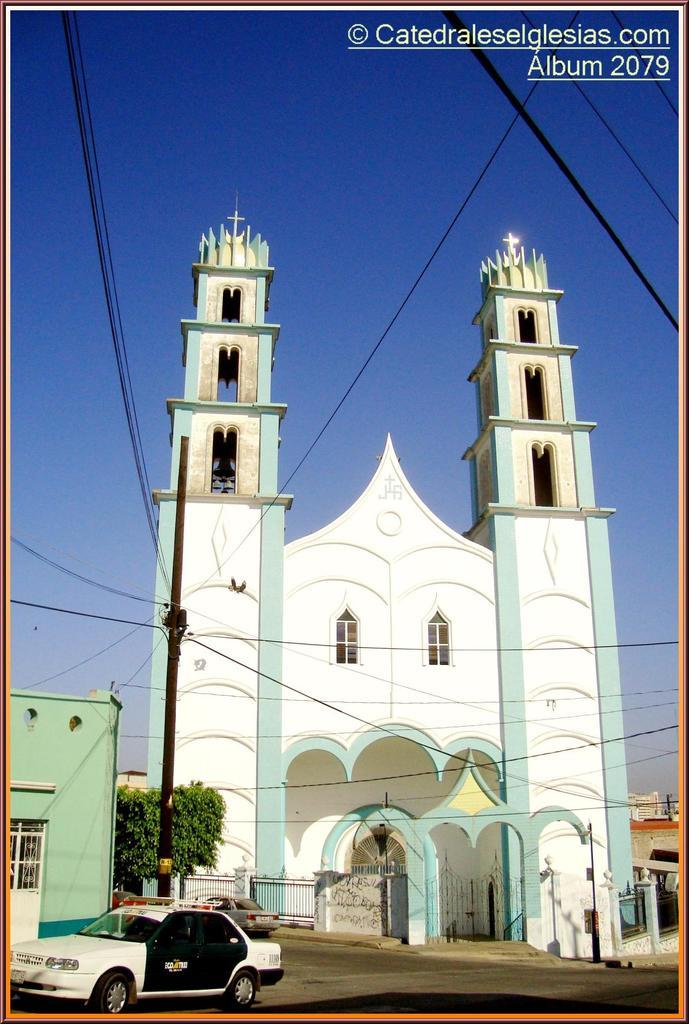<image>
Present a compact description of the photo's key features. A blue and white cathedral was documented in album 2079. 